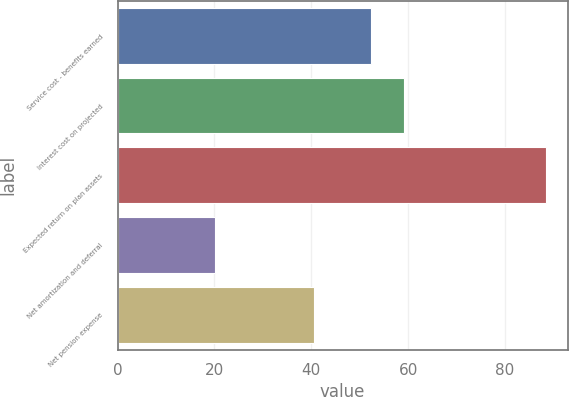<chart> <loc_0><loc_0><loc_500><loc_500><bar_chart><fcel>Service cost - benefits earned<fcel>Interest cost on projected<fcel>Expected return on plan assets<fcel>Net amortization and deferral<fcel>Net pension expense<nl><fcel>52.3<fcel>59.14<fcel>88.5<fcel>20.1<fcel>40.5<nl></chart> 